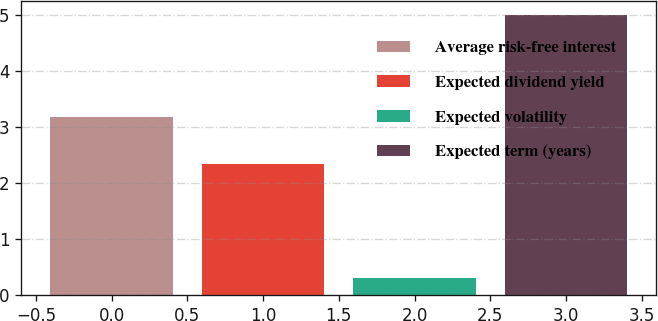<chart> <loc_0><loc_0><loc_500><loc_500><bar_chart><fcel>Average risk-free interest<fcel>Expected dividend yield<fcel>Expected volatility<fcel>Expected term (years)<nl><fcel>3.17<fcel>2.34<fcel>0.31<fcel>5<nl></chart> 